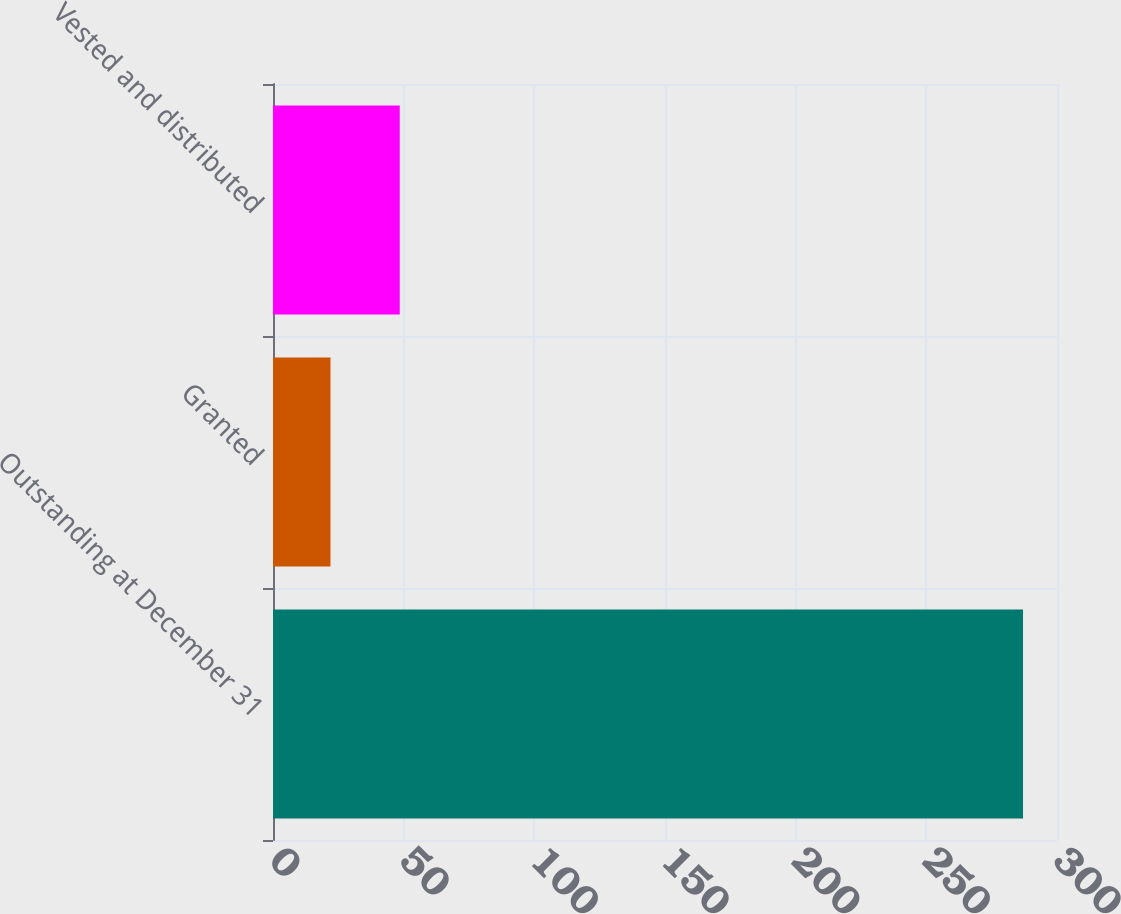Convert chart to OTSL. <chart><loc_0><loc_0><loc_500><loc_500><bar_chart><fcel>Outstanding at December 31<fcel>Granted<fcel>Vested and distributed<nl><fcel>287<fcel>22<fcel>48.5<nl></chart> 